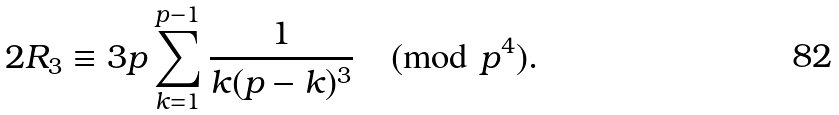Convert formula to latex. <formula><loc_0><loc_0><loc_500><loc_500>2 R _ { 3 } \equiv 3 p \sum _ { k = 1 } ^ { p - 1 } \frac { 1 } { k ( p - k ) ^ { 3 } } \pmod { p ^ { 4 } } .</formula> 